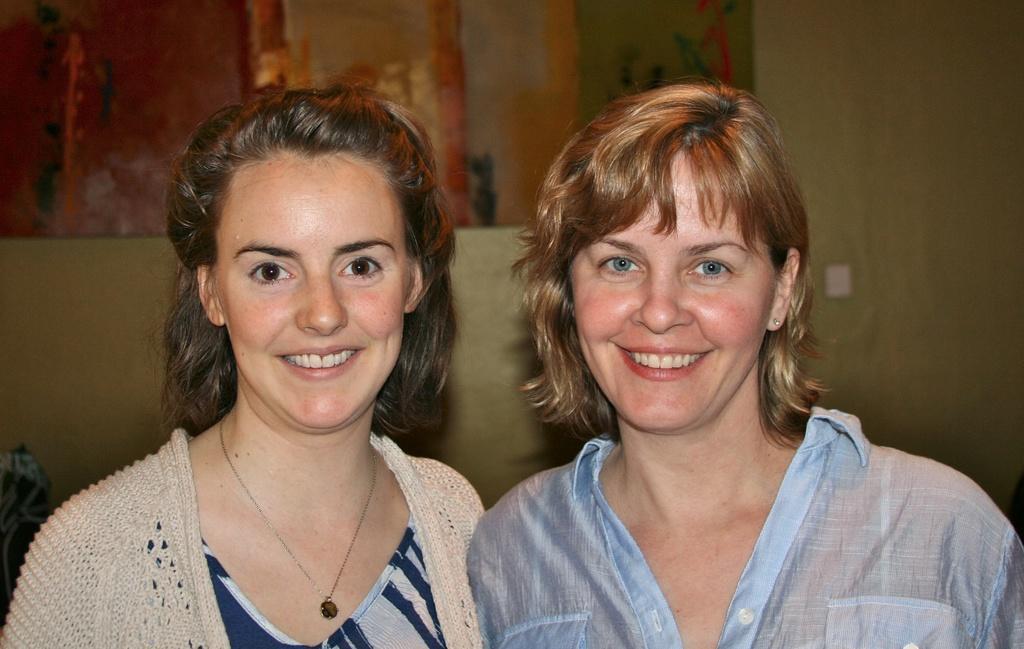Could you give a brief overview of what you see in this image? In this image in the foreground there are two women who are standing and smiling, and in the background there is a wall. 